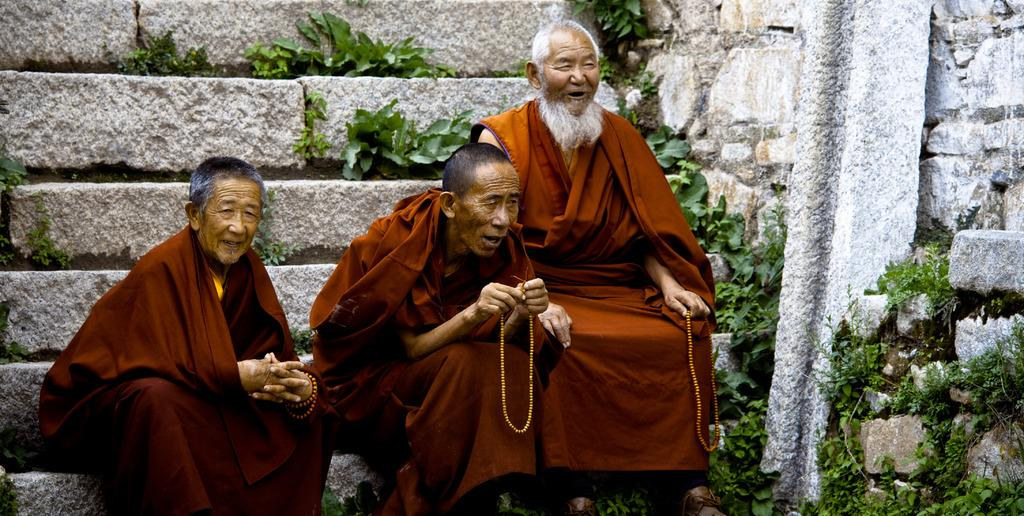How many people are present in the image? There are three people in the image. What are the people doing in the image? The people are sitting on steps. What are two of the people holding? Two of the people are holding chains. What type of vegetation can be seen in the image? There are plants in the image. What architectural feature is present in the image? There is a stone pillar in the image. What is the background of the image made of? There is a wall in the image. What does the mom say to the pigs in the image? There is no mom or pigs present in the image. How many cents are visible on the steps in the image? There are no cents visible on the steps in the image. 